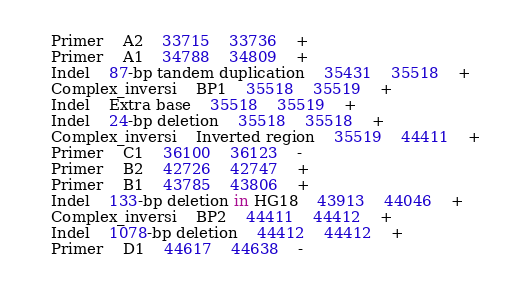<code> <loc_0><loc_0><loc_500><loc_500><_SQL_>Primer	A2	33715	33736	+
Primer	A1	34788	34809	+
Indel	87-bp tandem duplication	35431	35518	+
Complex_inversi	BP1	35518	35519	+
Indel	Extra base	35518	35519	+
Indel	24-bp deletion	35518	35518	+
Complex_inversi	Inverted region	35519	44411	+
Primer	C1	36100	36123	-
Primer	B2	42726	42747	+
Primer	B1	43785	43806	+
Indel	133-bp deletion in HG18	43913	44046	+
Complex_inversi	BP2	44411	44412	+
Indel	1078-bp deletion	44412	44412	+
Primer	D1	44617	44638	-
</code> 